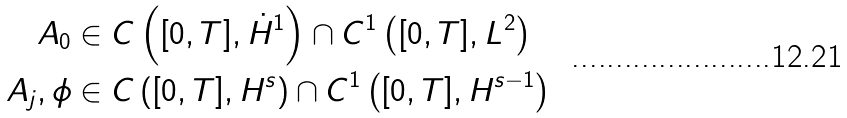Convert formula to latex. <formula><loc_0><loc_0><loc_500><loc_500>A _ { 0 } & \in C \left ( [ 0 , T ] , \dot { H } ^ { 1 } \right ) \cap C ^ { 1 } \left ( [ 0 , T ] , L ^ { 2 } \right ) \\ A _ { j } , \phi & \in C \left ( [ 0 , T ] , H ^ { s } \right ) \cap C ^ { 1 } \left ( [ 0 , T ] , H ^ { s - 1 } \right )</formula> 